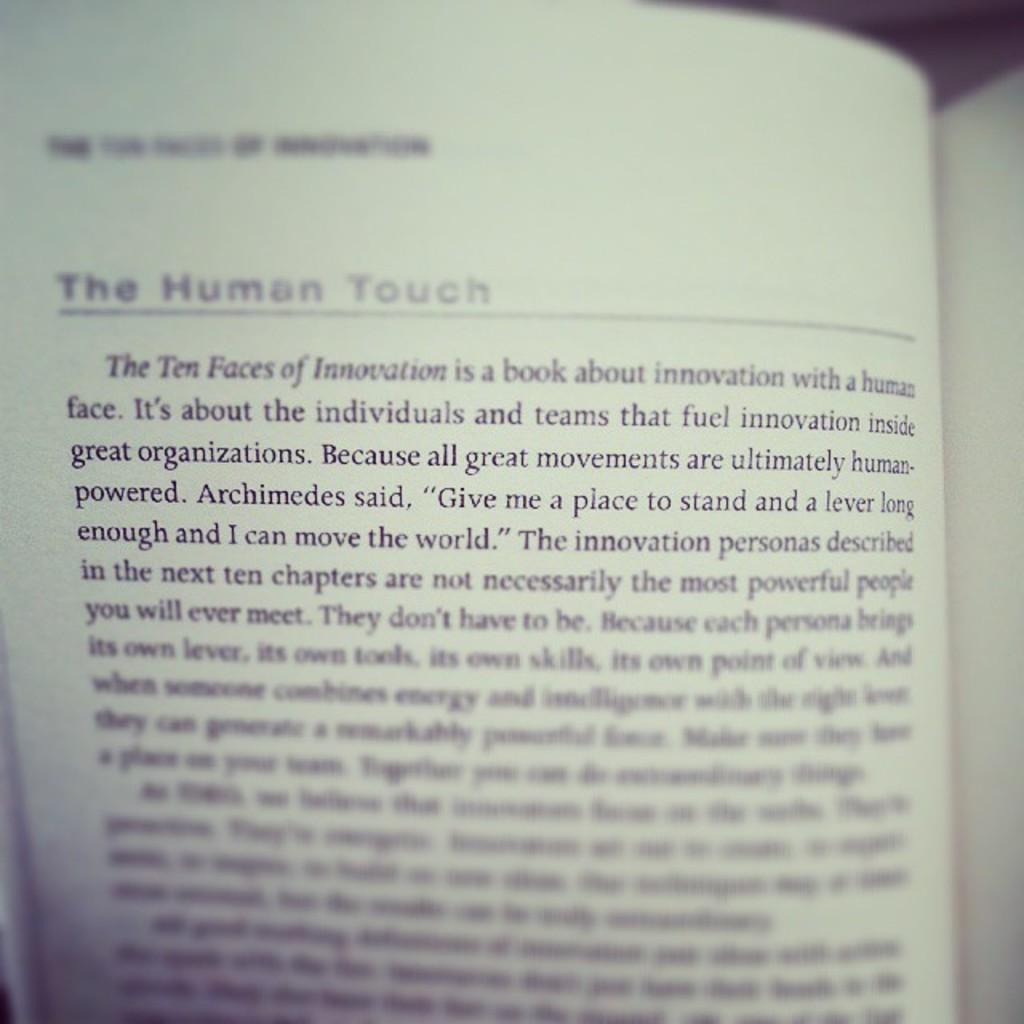Who is speaking in the text?
Your response must be concise. Archimedes. 